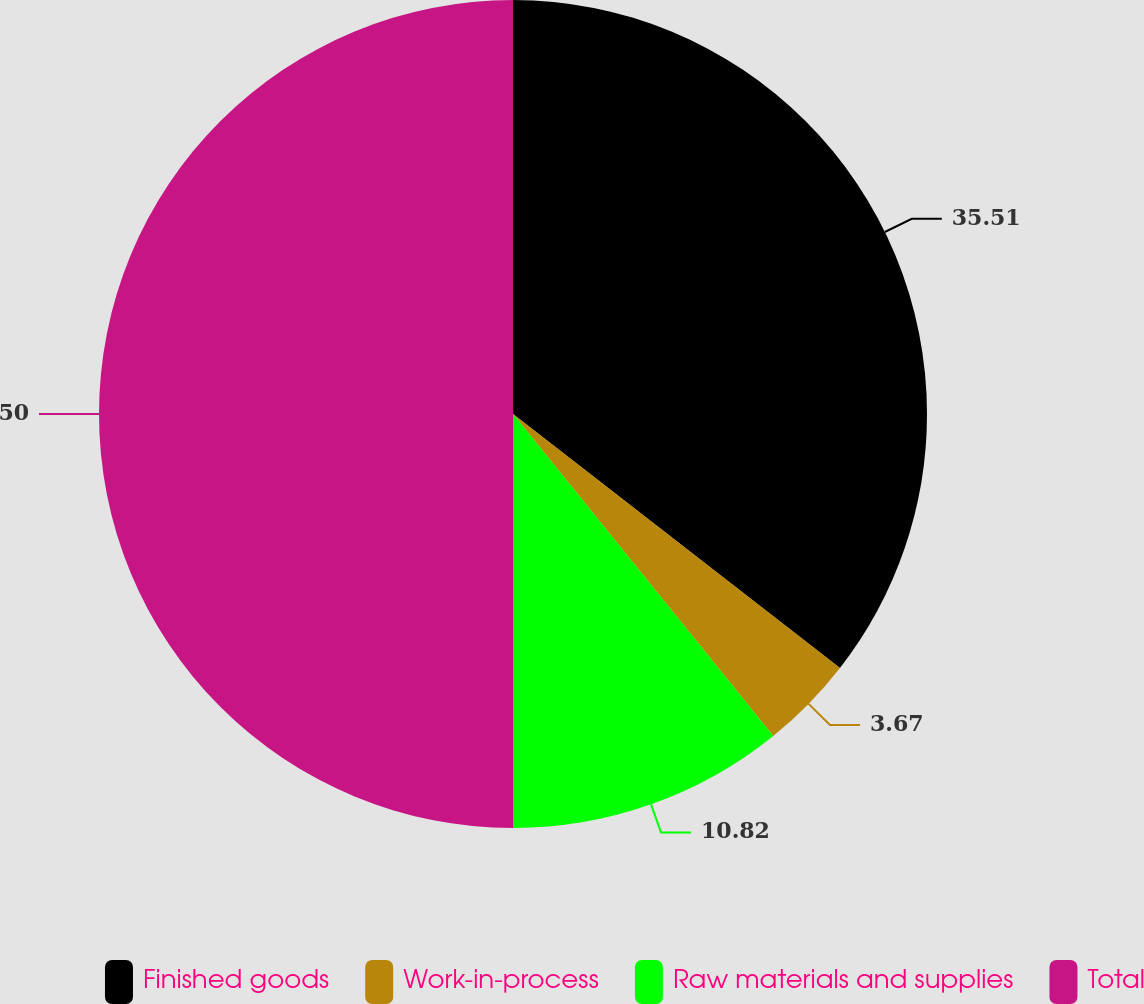Convert chart. <chart><loc_0><loc_0><loc_500><loc_500><pie_chart><fcel>Finished goods<fcel>Work-in-process<fcel>Raw materials and supplies<fcel>Total<nl><fcel>35.51%<fcel>3.67%<fcel>10.82%<fcel>50.0%<nl></chart> 